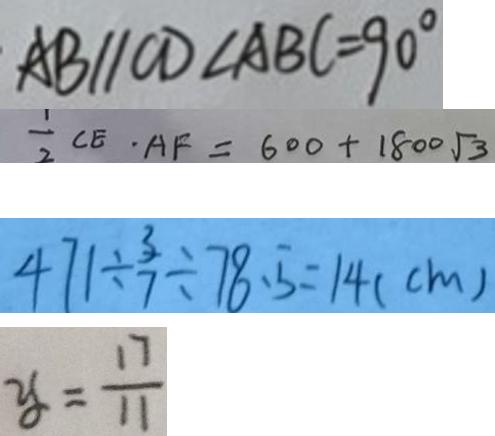Convert formula to latex. <formula><loc_0><loc_0><loc_500><loc_500>A B / / C D \angle A B C = 9 0 ^ { \circ } 
 \frac { 1 } { 2 } C E \cdot A F = 6 0 0 + 1 8 0 0 \sqrt { 3 } 
 4 7 1 \div \frac { 3 } { 7 } \div 7 8 . 5 = 1 4 ( c m ) 
 y = \frac { 1 7 } { 1 1 }</formula> 